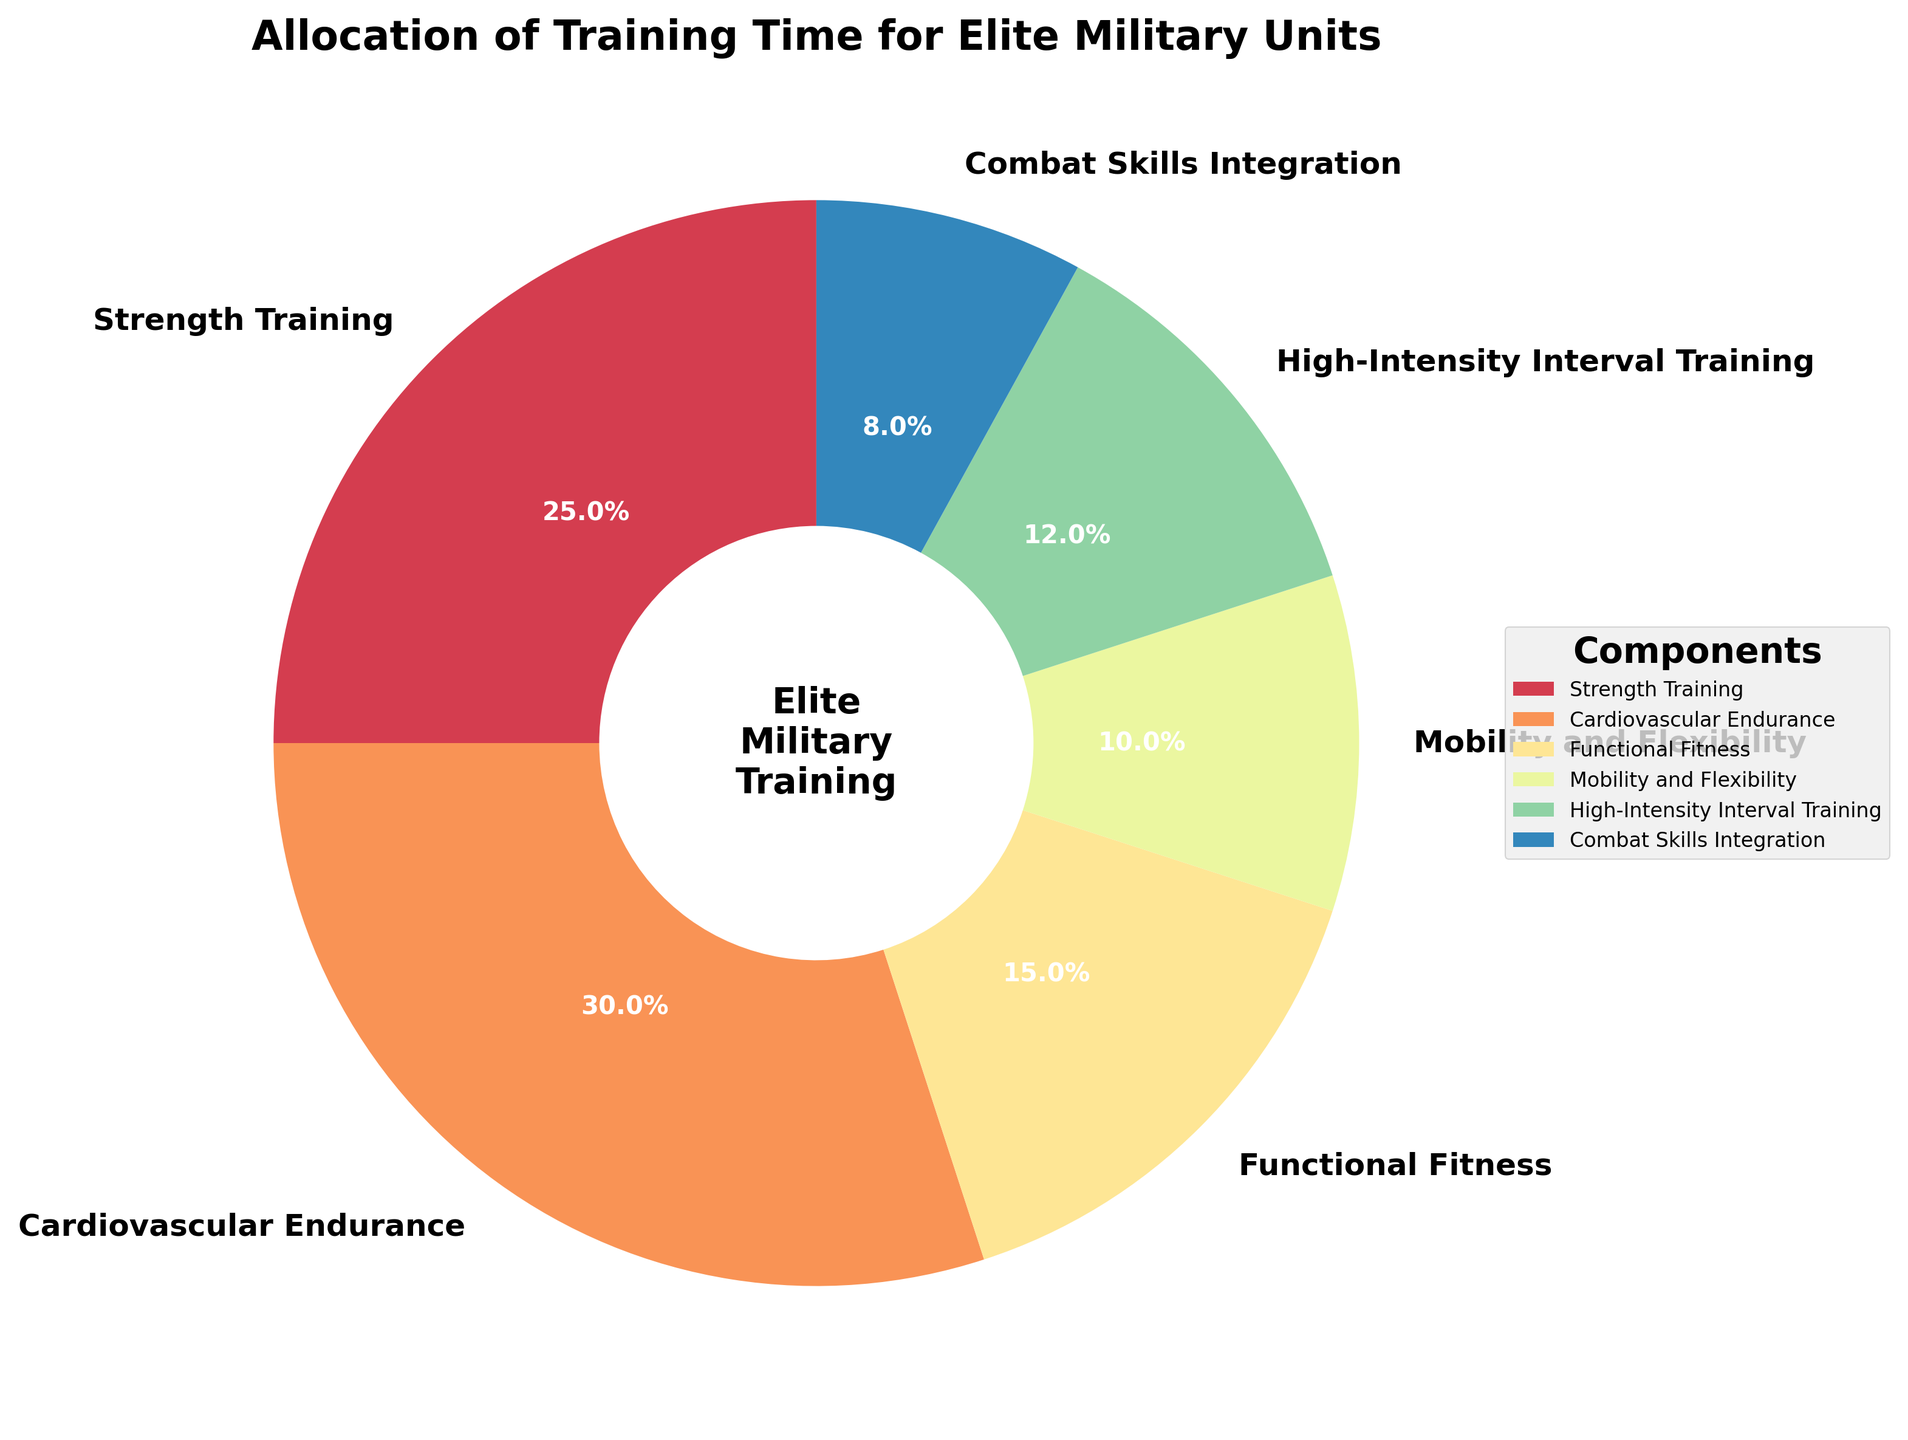Which component has the largest allocation of training time? Reviewing the pie chart, Cardiovascular Endurance has the largest section, accounting for 30% of the training time.
Answer: Cardiovascular Endurance Which component has the smallest allocation of training time? From the pie chart, Combat Skills Integration has the smallest slice, accounting for 8% of the training time.
Answer: Combat Skills Integration How much more time is allocated to Strength Training than Combat Skills Integration? Strength Training is 25%, and Combat Skills Integration is 8%. The difference is 25% - 8% = 17%.
Answer: 17% How does Mobility and Flexibility training compare to High-Intensity Interval Training (HIIT) in terms of percentage? Mobility and Flexibility is 10%, and HIIT is 12%. 12% is greater than 10%.
Answer: HIIT is greater What is the total percentage of time allocated to Cardiovascular Endurance and Strength Training combined? Cardiovascular Endurance is 30%, and Strength Training is 25%. The combined total is 30% + 25% = 55%.
Answer: 55% What percentage of training time is dedicated to Functional Fitness and Mobility and Flexibility together? Functional Fitness is 15%, and Mobility and Flexibility is 10%. Adding them together gives 15% + 10% = 25%.
Answer: 25% What is the average percentage of the time allocated to Strength Training, Functional Fitness, and HIIT? Strength Training is 25%, Functional Fitness is 15%, and HIIT is 12%. Their total is 25% + 15% + 12% = 52%, and the average is 52% / 3 ≈ 17.3%.
Answer: 17.3% Which component has a larger percentage allocation: HIIT or Mobility and Flexibility? HIIT is 12%, while Mobility and Flexibility is 10%. 12% is larger than 10%.
Answer: HIIT How many components have an allocation higher than 10%? From the pie chart, the components with higher than 10% are Strength Training (25%), Cardiovascular Endurance (30%), Functional Fitness (15%), and HIIT (12%). There are 4 such components.
Answer: 4 components 